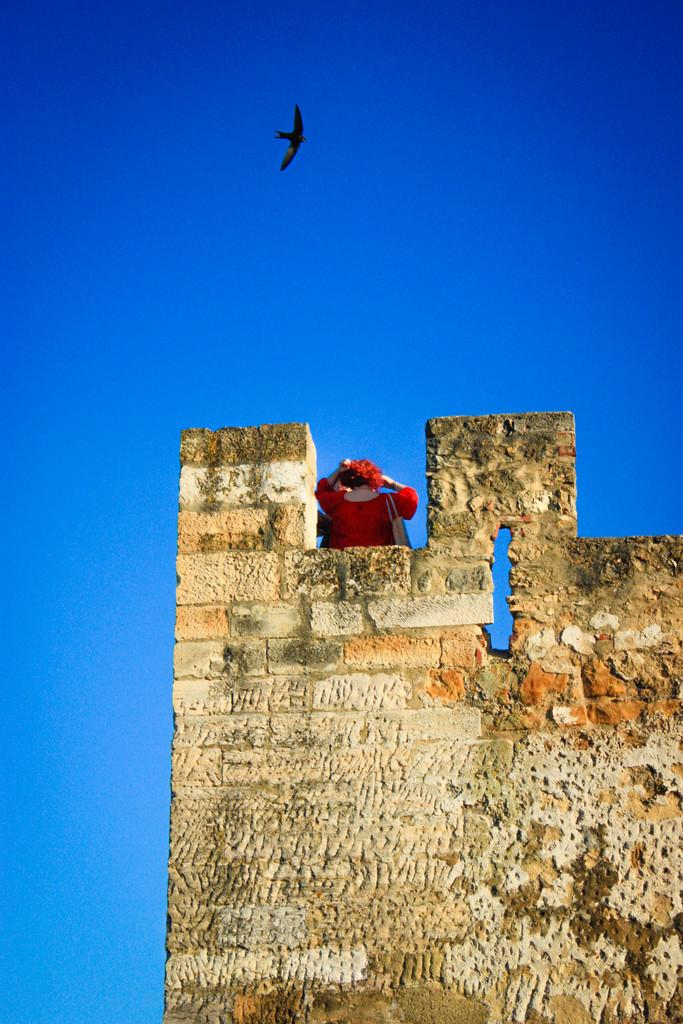Where is the girl located in the image? The girl is standing at the top of a building in the image. What is happening in the sky at the top of the image? An eagle is flying in the sky at the top of the image. How many snails are crawling on the girl's shoes in the image? There are no snails present in the image; the girl is standing at the top of a building, and an eagle is flying in the sky. 